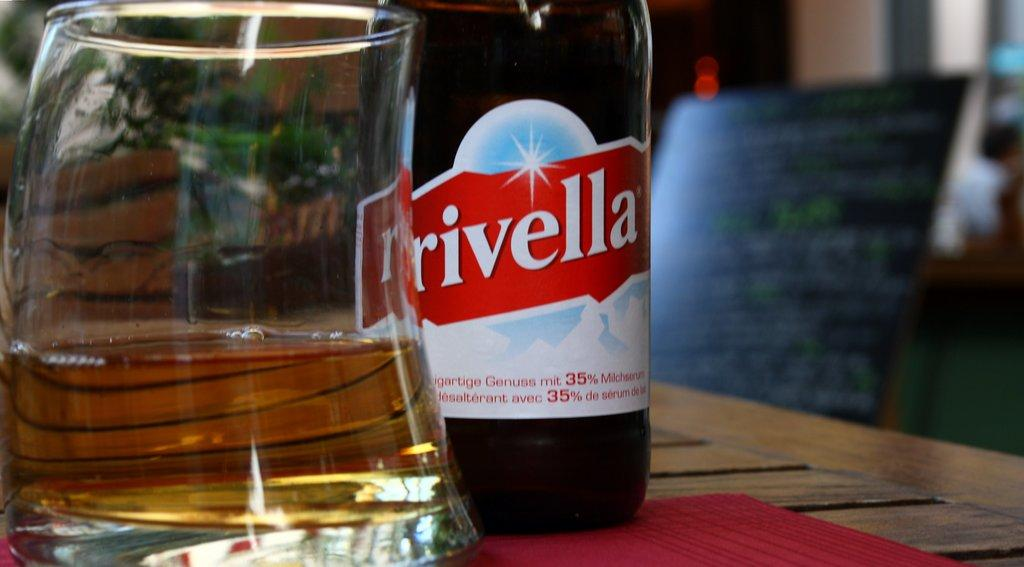<image>
Offer a succinct explanation of the picture presented. A bottle of Rivella is next to a glass. 